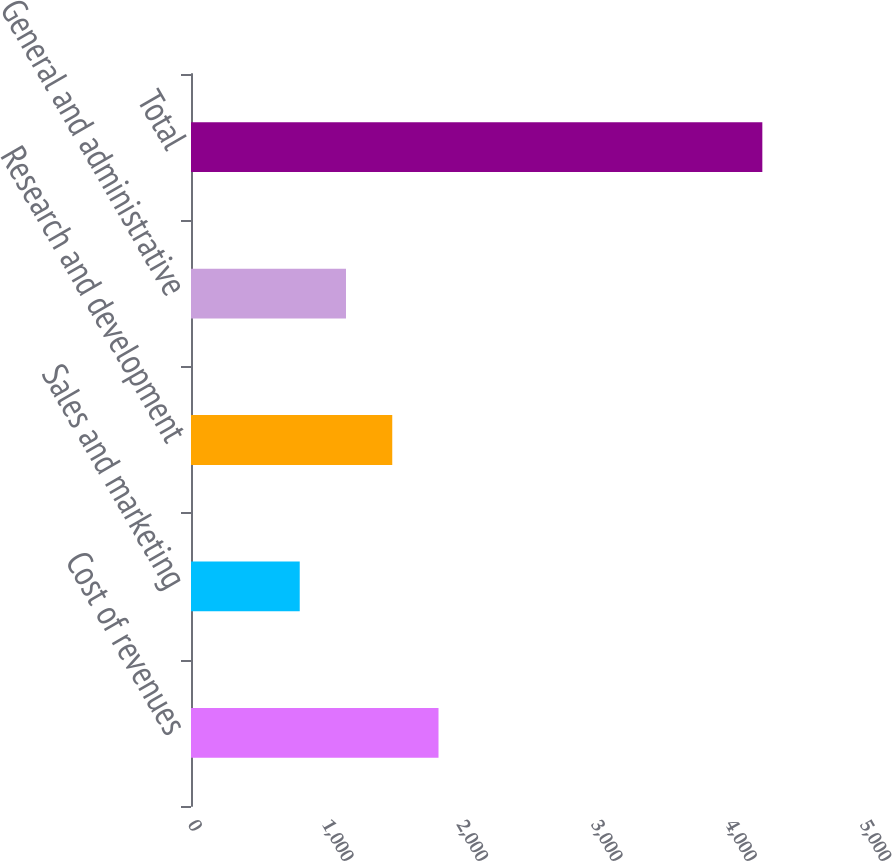Convert chart to OTSL. <chart><loc_0><loc_0><loc_500><loc_500><bar_chart><fcel>Cost of revenues<fcel>Sales and marketing<fcel>Research and development<fcel>General and administrative<fcel>Total<nl><fcel>1841.6<fcel>809<fcel>1497.4<fcel>1153.2<fcel>4251<nl></chart> 